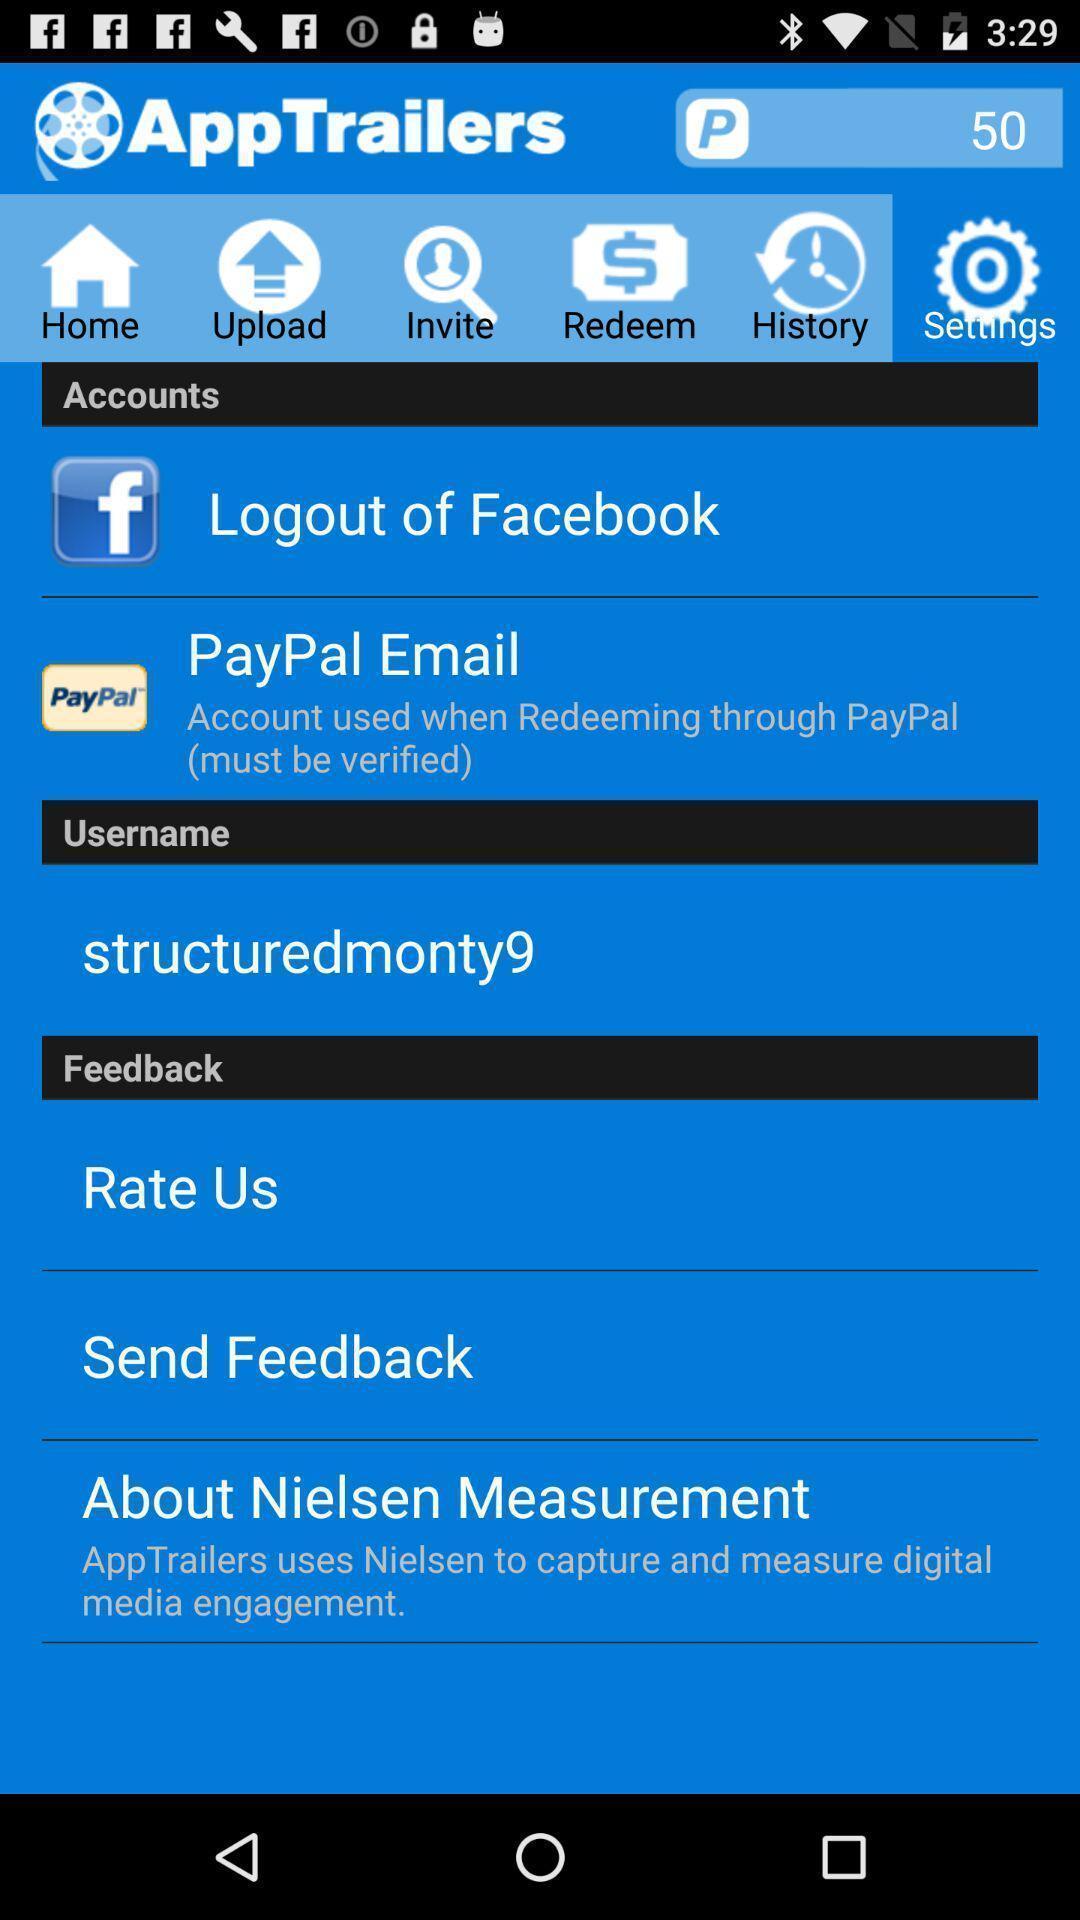Provide a textual representation of this image. Screen showing setting page with various options. 